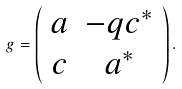<formula> <loc_0><loc_0><loc_500><loc_500>g = \left ( \begin{array} { c c } { a } & { { - q c ^ { * } } } \\ { c } & { { a ^ { * } } } \end{array} \right ) .</formula> 